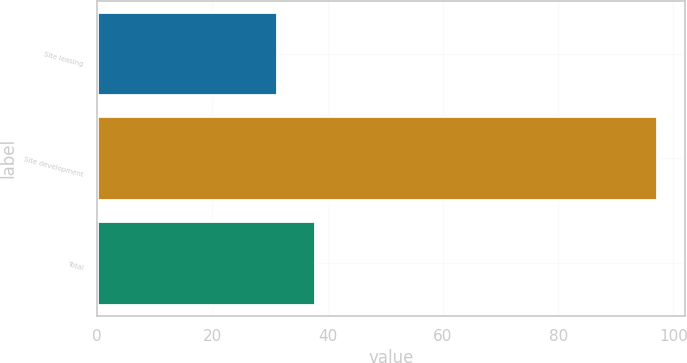Convert chart to OTSL. <chart><loc_0><loc_0><loc_500><loc_500><bar_chart><fcel>Site leasing<fcel>Site development<fcel>Total<nl><fcel>31.2<fcel>97.2<fcel>37.8<nl></chart> 